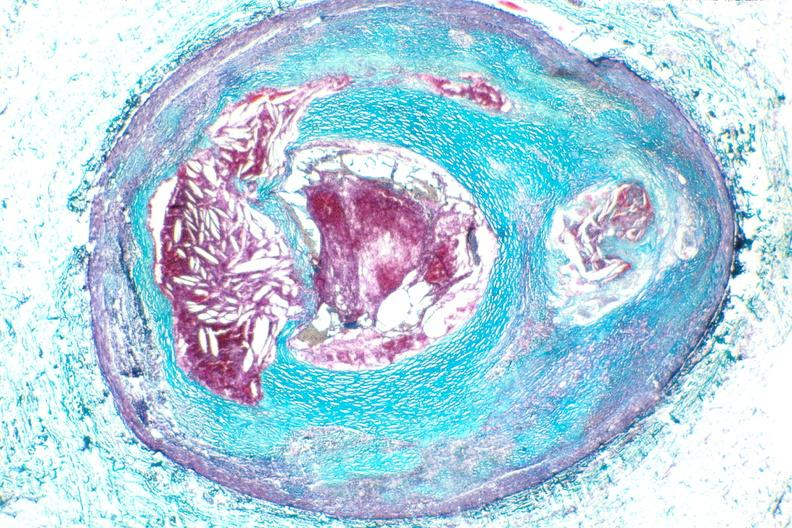what is present?
Answer the question using a single word or phrase. Vasculature 